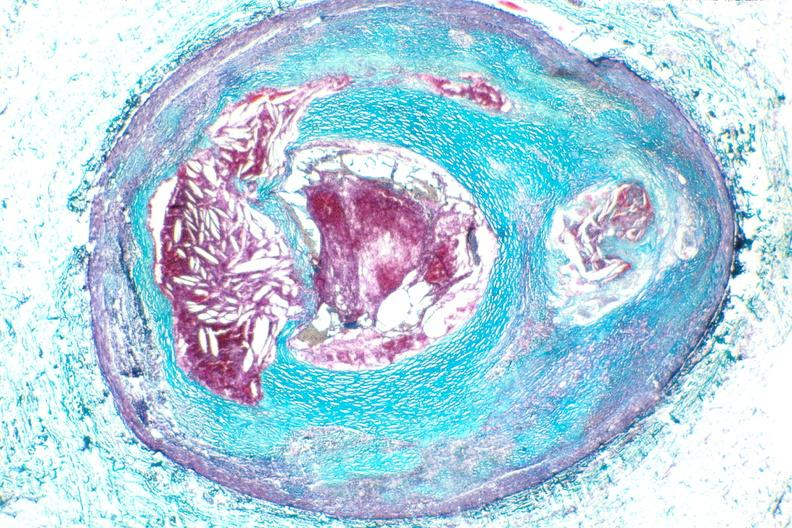what is present?
Answer the question using a single word or phrase. Vasculature 